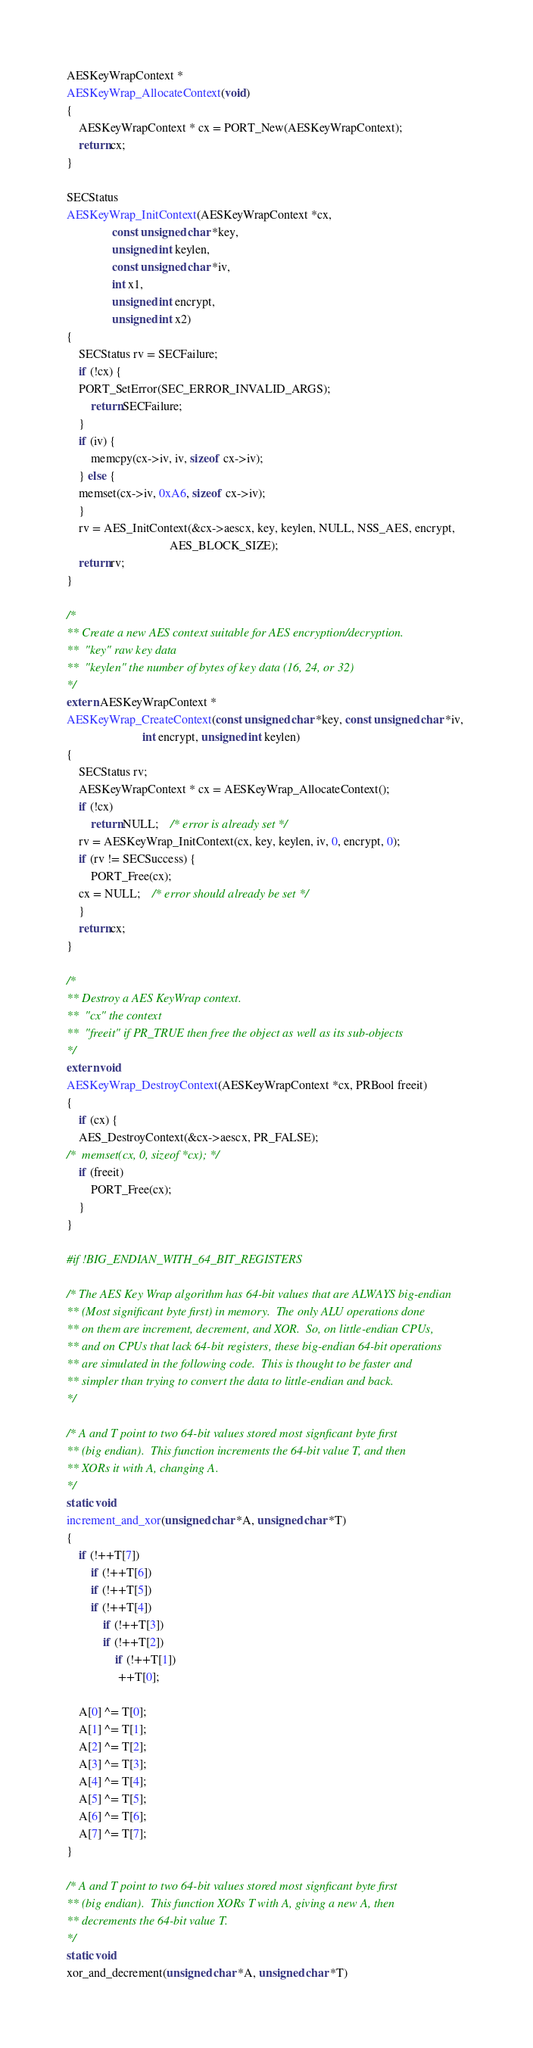Convert code to text. <code><loc_0><loc_0><loc_500><loc_500><_C_>AESKeyWrapContext * 
AESKeyWrap_AllocateContext(void)
{
    AESKeyWrapContext * cx = PORT_New(AESKeyWrapContext);
    return cx;
}

SECStatus  
AESKeyWrap_InitContext(AESKeyWrapContext *cx, 
		       const unsigned char *key, 
		       unsigned int keylen,
		       const unsigned char *iv, 
		       int x1,
		       unsigned int encrypt,
		       unsigned int x2)
{
    SECStatus rv = SECFailure;
    if (!cx) {
	PORT_SetError(SEC_ERROR_INVALID_ARGS);
    	return SECFailure;
    }
    if (iv) {
    	memcpy(cx->iv, iv, sizeof cx->iv);
    } else {
	memset(cx->iv, 0xA6, sizeof cx->iv);
    }
    rv = AES_InitContext(&cx->aescx, key, keylen, NULL, NSS_AES, encrypt, 
                                  AES_BLOCK_SIZE);
    return rv;
}

/*
** Create a new AES context suitable for AES encryption/decryption.
** 	"key" raw key data
** 	"keylen" the number of bytes of key data (16, 24, or 32)
*/
extern AESKeyWrapContext *
AESKeyWrap_CreateContext(const unsigned char *key, const unsigned char *iv, 
                         int encrypt, unsigned int keylen)
{
    SECStatus rv;
    AESKeyWrapContext * cx = AESKeyWrap_AllocateContext();
    if (!cx) 
    	return NULL;	/* error is already set */
    rv = AESKeyWrap_InitContext(cx, key, keylen, iv, 0, encrypt, 0);
    if (rv != SECSuccess) {
        PORT_Free(cx);
	cx = NULL; 	/* error should already be set */
    }
    return cx;
}

/*
** Destroy a AES KeyWrap context.
**	"cx" the context
**	"freeit" if PR_TRUE then free the object as well as its sub-objects
*/
extern void 
AESKeyWrap_DestroyContext(AESKeyWrapContext *cx, PRBool freeit)
{
    if (cx) {
	AES_DestroyContext(&cx->aescx, PR_FALSE);
/*	memset(cx, 0, sizeof *cx); */
	if (freeit)
	    PORT_Free(cx);
    }
}

#if !BIG_ENDIAN_WITH_64_BIT_REGISTERS

/* The AES Key Wrap algorithm has 64-bit values that are ALWAYS big-endian
** (Most significant byte first) in memory.  The only ALU operations done
** on them are increment, decrement, and XOR.  So, on little-endian CPUs,
** and on CPUs that lack 64-bit registers, these big-endian 64-bit operations
** are simulated in the following code.  This is thought to be faster and
** simpler than trying to convert the data to little-endian and back.
*/

/* A and T point to two 64-bit values stored most signficant byte first
** (big endian).  This function increments the 64-bit value T, and then
** XORs it with A, changing A.
*/ 
static void
increment_and_xor(unsigned char *A, unsigned char *T)
{
    if (!++T[7])
        if (!++T[6])
	    if (!++T[5])
		if (!++T[4])
		    if (!++T[3])
			if (!++T[2])
			    if (!++T[1])
				 ++T[0];

    A[0] ^= T[0];
    A[1] ^= T[1];
    A[2] ^= T[2];
    A[3] ^= T[3];
    A[4] ^= T[4];
    A[5] ^= T[5];
    A[6] ^= T[6];
    A[7] ^= T[7];
}

/* A and T point to two 64-bit values stored most signficant byte first
** (big endian).  This function XORs T with A, giving a new A, then 
** decrements the 64-bit value T.
*/ 
static void
xor_and_decrement(unsigned char *A, unsigned char *T)</code> 